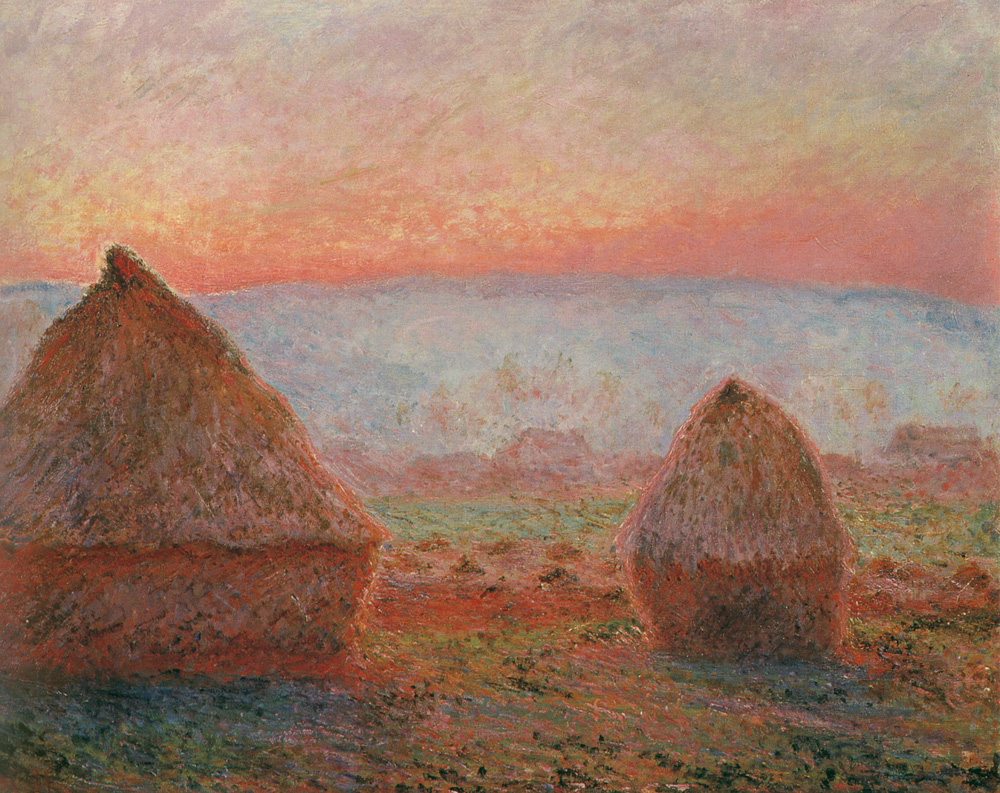Can you tell me more about the artistic techniques used in this painting? This painting employs classic impressionist techniques, characterized by visible, expressive brushstrokes that blend colors and shapes at a distance but appear distinct up close. The technique captures the essence and light of the scene rather than its precise details. This method is particularly effective in rendering the atmospheric effects of the sunset and its impact on the color and textures of the haystacks and the landscape. 